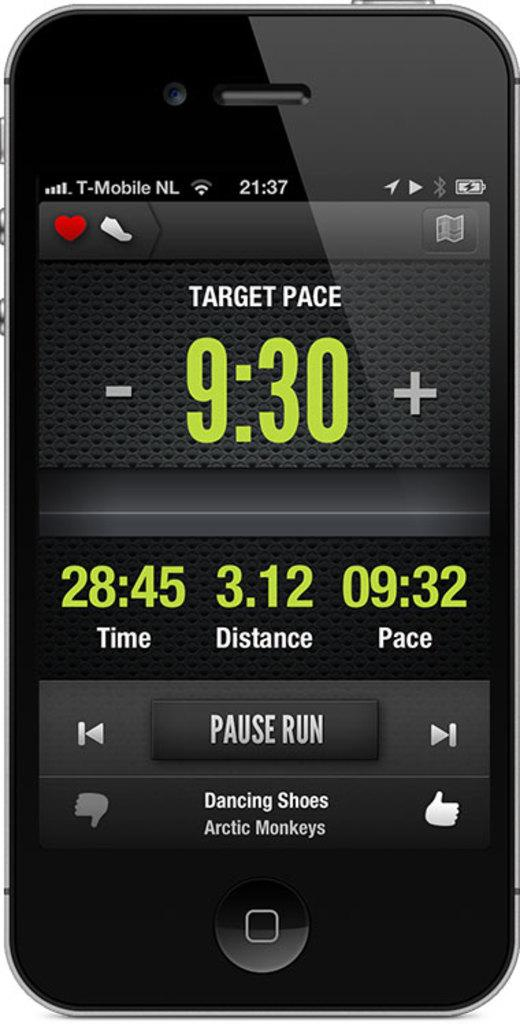<image>
Render a clear and concise summary of the photo. Phone with a tracking app with target pace set at 9:30. 